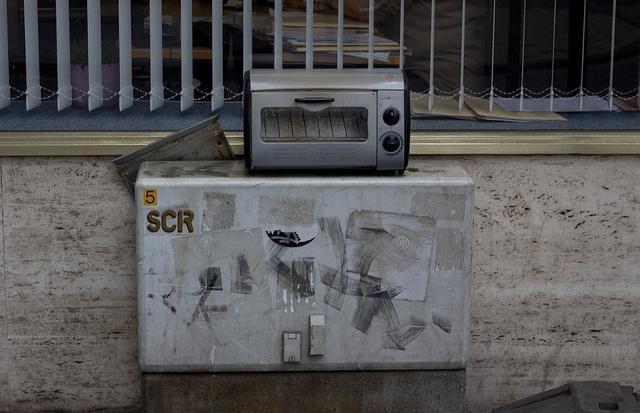How many cars are to the right of the pole?
Give a very brief answer. 0. 